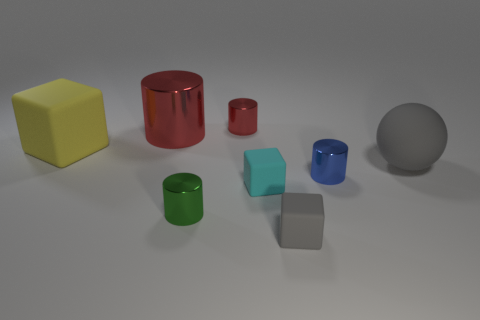Add 1 big purple balls. How many objects exist? 9 Subtract all big blocks. How many blocks are left? 2 Subtract 1 spheres. How many spheres are left? 0 Subtract all green cylinders. How many cylinders are left? 3 Subtract 1 gray cubes. How many objects are left? 7 Subtract all cubes. How many objects are left? 5 Subtract all red cylinders. Subtract all blue cubes. How many cylinders are left? 2 Subtract all blue blocks. How many green cylinders are left? 1 Subtract all small gray spheres. Subtract all large red things. How many objects are left? 7 Add 1 large blocks. How many large blocks are left? 2 